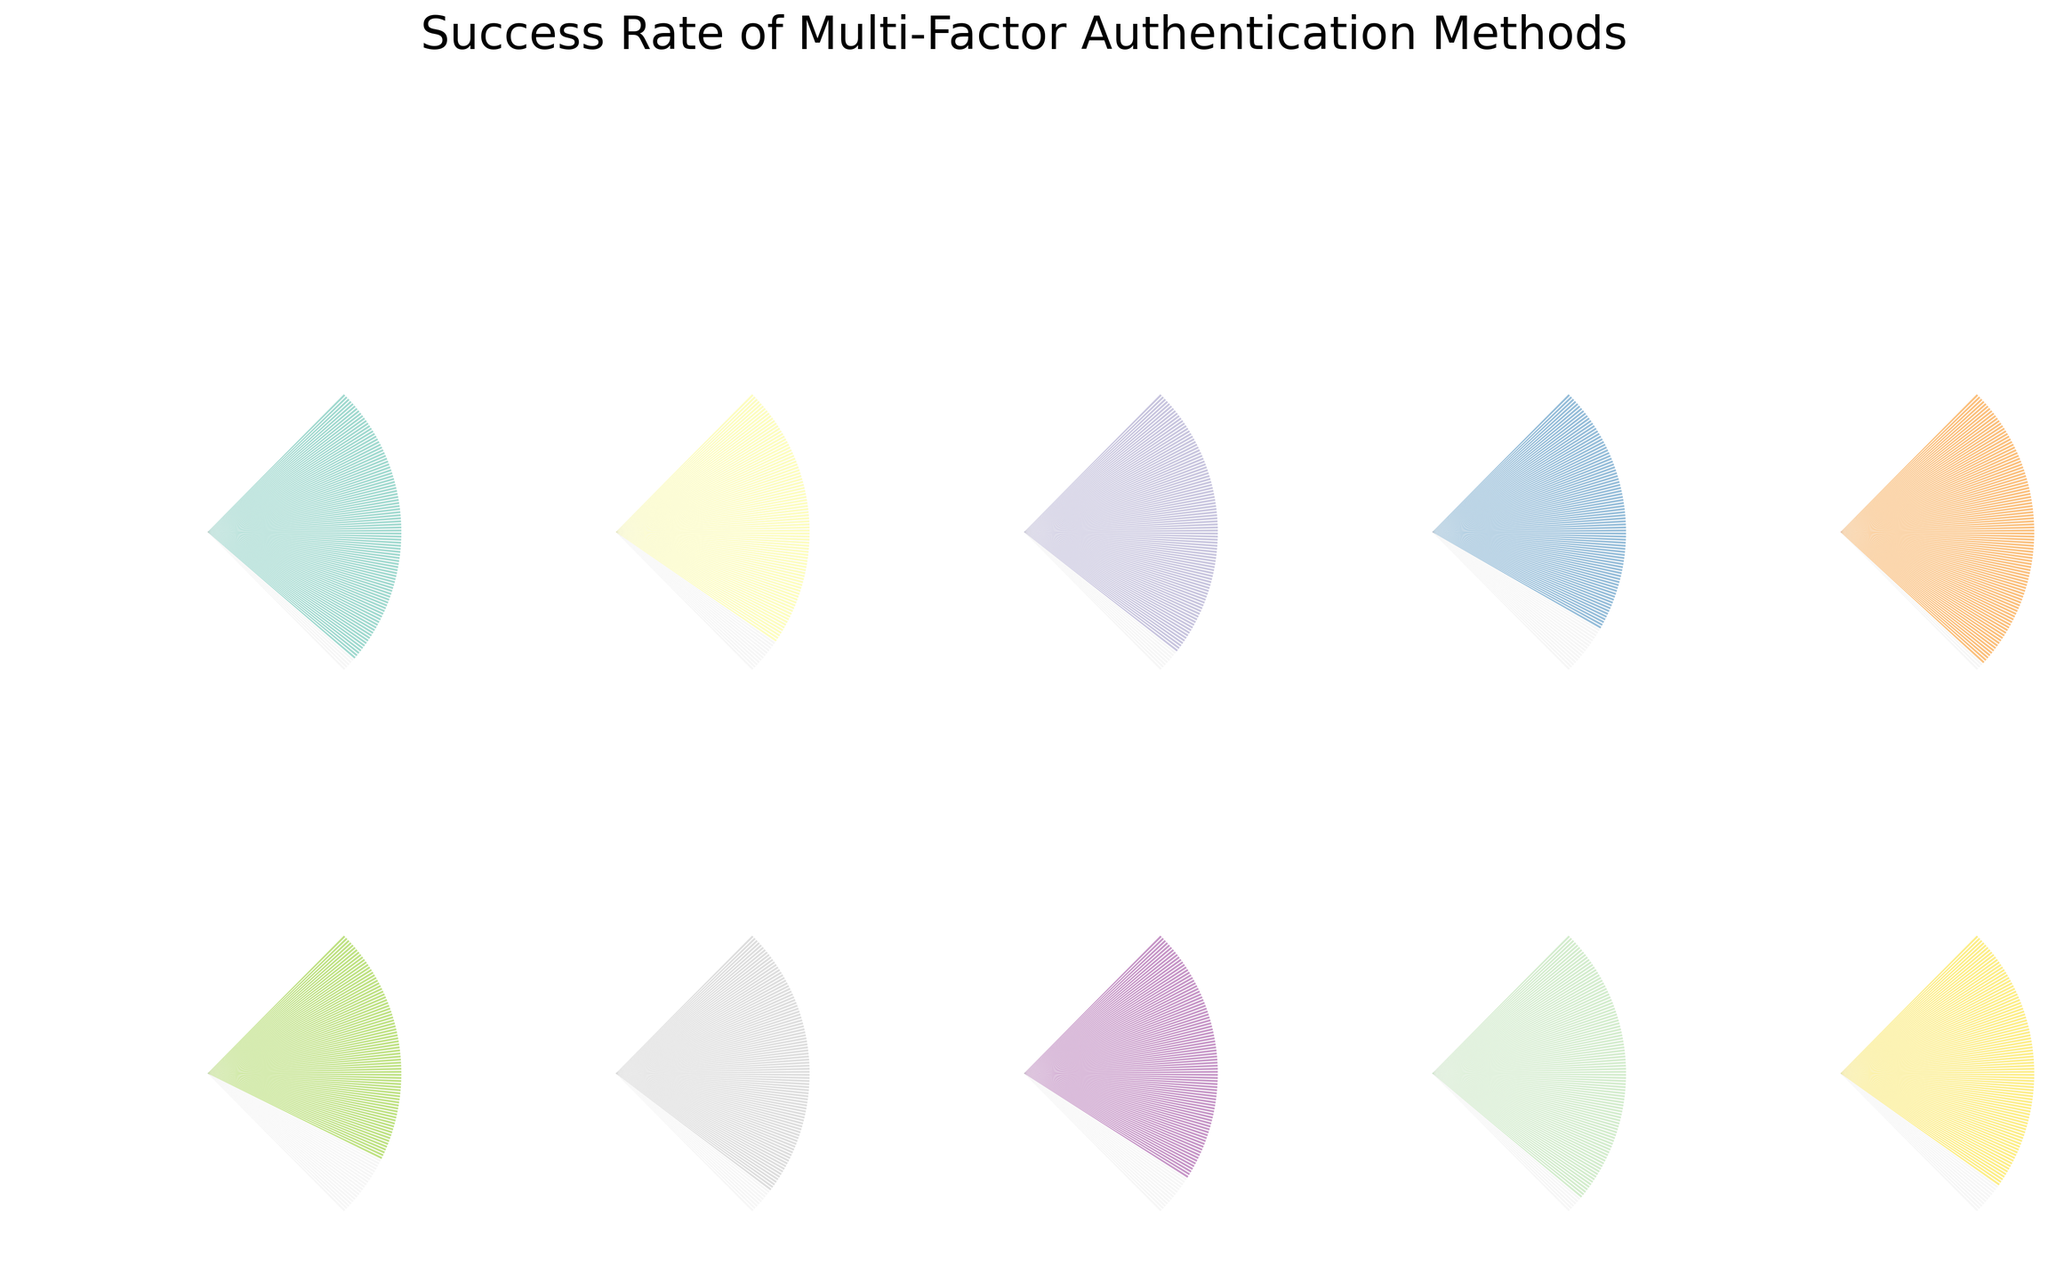What is the success rate of the Windows Hello Facial Recognition method? Look at the corresponding gauge chart for "Windows Hello Facial Recognition" and read the percentage value displayed.
Answer: 95.2% Which authentication method has the lowest success rate? Identify the method with the smallest percentage value displayed on its gauge chart.
Answer: Email One-Time Passcode What is the average success rate of the FIDO2 Security Key and Microsoft Authenticator App methods? Add the success rates for "FIDO2 Security Key" (88.7) and "Microsoft Authenticator App" (92.5), and then divide by 2. Calculation: (88.7 + 92.5) / 2 = 90.6
Answer: 90.6 How many methods have a success rate higher than 90%? Count the number of gauge charts with a value greater than 90%.
Answer: 6 Which method has the highest success rate, and what is that rate? Identify the method with the largest percentage value on its gauge chart.
Answer: Biometric Fingerprint, 97.8% What is the difference in success rate between Azure AD Conditional Access and RSA SecurID Token? Subtract the success rate of "RSA SecurID Token" (86.4) from "Azure AD Conditional Access" (94.9). Calculation: 94.9 - 86.4 = 8.5
Answer: 8.5 List all methods with a success rate within the range of 85% to 90%. Identify the methods whose gauge charts display values between 85% and 90% inclusively.
Answer: FIDO2 Security Key, Google Authenticator App, RSA SecurID Token What is the median success rate of all the methods? Arrange the success rates in ascending order and find the middle value. For even numbers of data points, average the two central values. Sorted success rates: 79.3, 83.1, 86.4, 88.7, 89.2, 91.6, 92.5, 94.9, 95.2, 97.8. Median calculation: (89.2 + 91.6) / 2 = 90.4
Answer: 90.4 